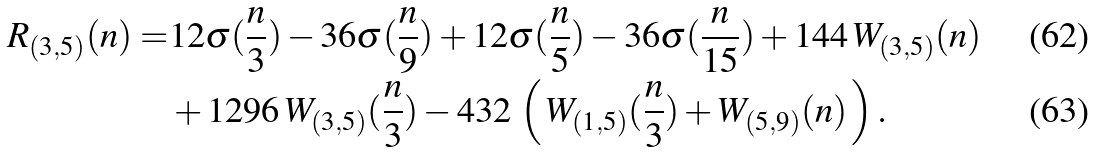Convert formula to latex. <formula><loc_0><loc_0><loc_500><loc_500>R _ { ( 3 , 5 ) } ( n ) = & 1 2 \sigma ( \frac { n } { 3 } ) - 3 6 \sigma ( \frac { n } { 9 } ) + 1 2 \sigma ( \frac { n } { 5 } ) - 3 6 \sigma ( \frac { n } { 1 5 } ) + 1 4 4 \, W _ { ( 3 , 5 ) } ( n ) \\ & + 1 2 9 6 \, W _ { ( 3 , 5 ) } ( \frac { n } { 3 } ) - 4 3 2 \, \left ( \, W _ { ( 1 , 5 ) } ( \frac { n } { 3 } ) + W _ { ( 5 , 9 ) } ( n ) \, \right ) .</formula> 